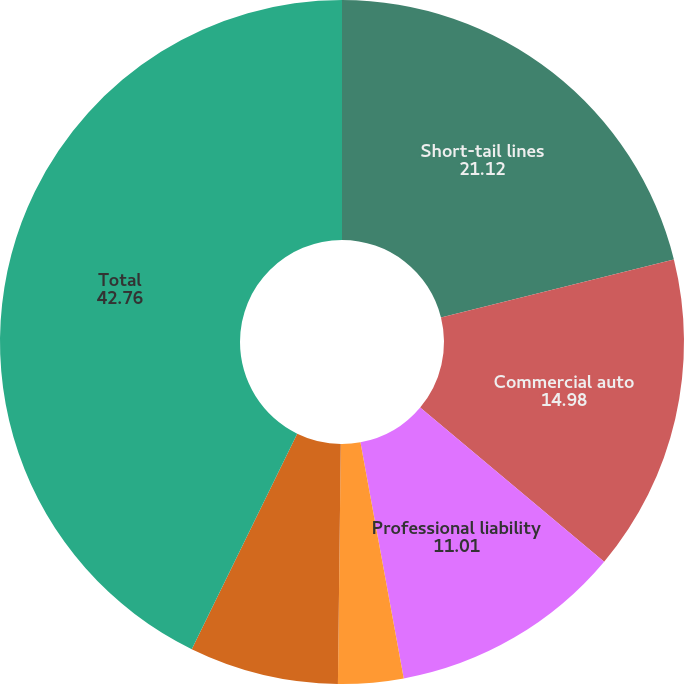<chart> <loc_0><loc_0><loc_500><loc_500><pie_chart><fcel>Short-tail lines<fcel>Commercial auto<fcel>Professional liability<fcel>Other liability<fcel>Workers' compensation<fcel>Total<nl><fcel>21.12%<fcel>14.98%<fcel>11.01%<fcel>3.08%<fcel>7.05%<fcel>42.76%<nl></chart> 